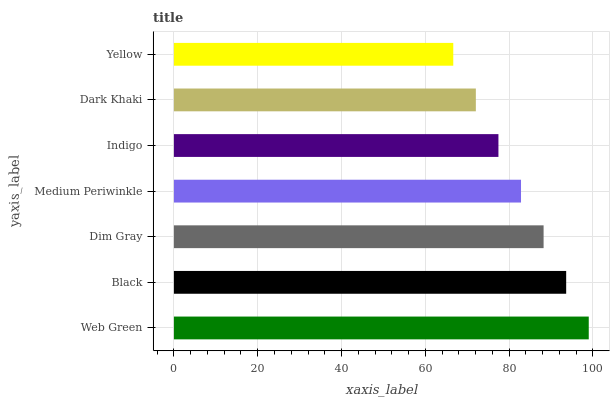Is Yellow the minimum?
Answer yes or no. Yes. Is Web Green the maximum?
Answer yes or no. Yes. Is Black the minimum?
Answer yes or no. No. Is Black the maximum?
Answer yes or no. No. Is Web Green greater than Black?
Answer yes or no. Yes. Is Black less than Web Green?
Answer yes or no. Yes. Is Black greater than Web Green?
Answer yes or no. No. Is Web Green less than Black?
Answer yes or no. No. Is Medium Periwinkle the high median?
Answer yes or no. Yes. Is Medium Periwinkle the low median?
Answer yes or no. Yes. Is Indigo the high median?
Answer yes or no. No. Is Black the low median?
Answer yes or no. No. 